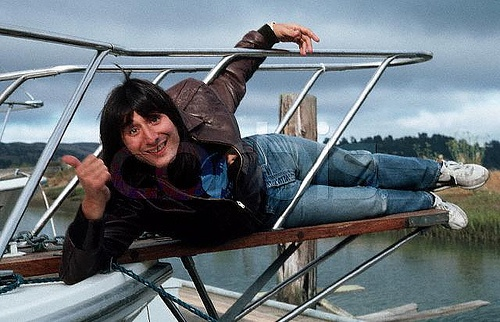Describe the objects in this image and their specific colors. I can see boat in darkgray, black, gray, and lightgray tones and people in darkgray, black, gray, blue, and maroon tones in this image. 